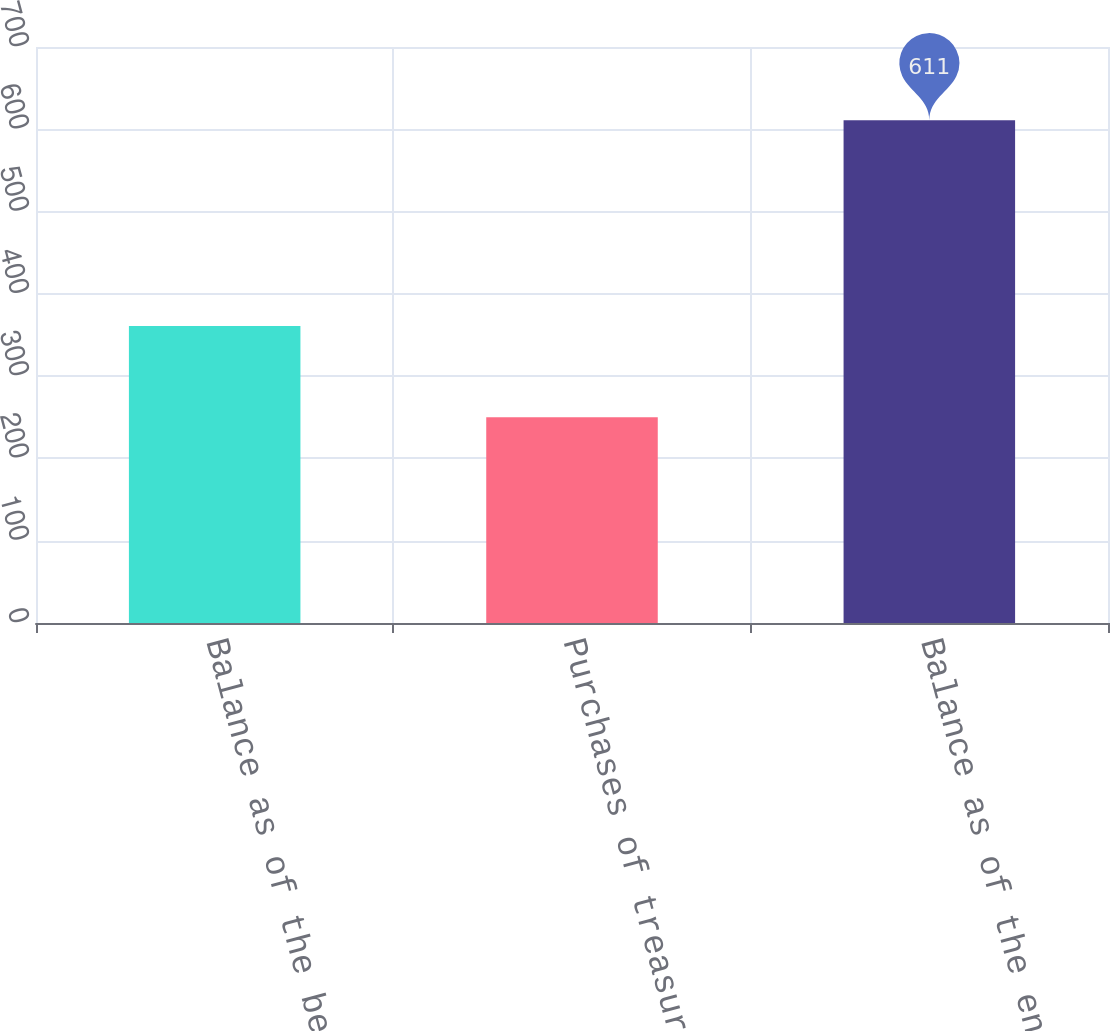Convert chart. <chart><loc_0><loc_0><loc_500><loc_500><bar_chart><fcel>Balance as of the beginning of<fcel>Purchases of treasury stock<fcel>Balance as of the end of the<nl><fcel>361<fcel>250<fcel>611<nl></chart> 